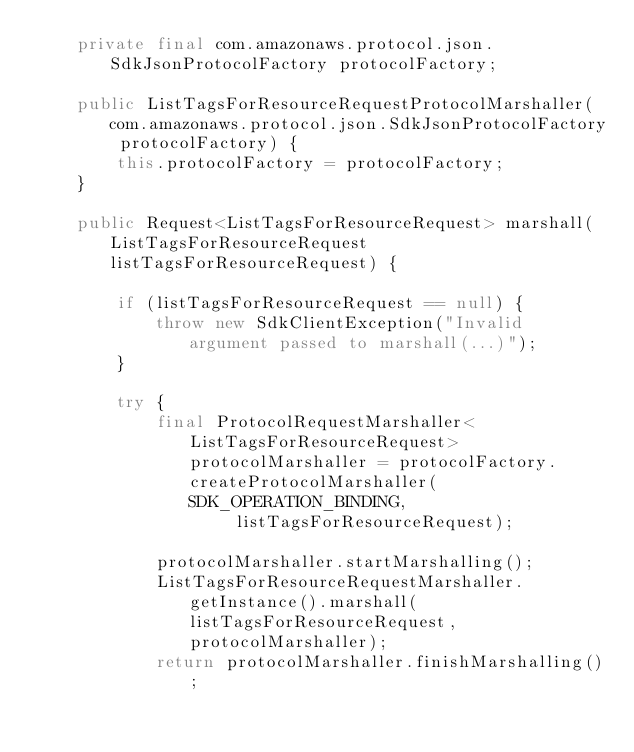<code> <loc_0><loc_0><loc_500><loc_500><_Java_>    private final com.amazonaws.protocol.json.SdkJsonProtocolFactory protocolFactory;

    public ListTagsForResourceRequestProtocolMarshaller(com.amazonaws.protocol.json.SdkJsonProtocolFactory protocolFactory) {
        this.protocolFactory = protocolFactory;
    }

    public Request<ListTagsForResourceRequest> marshall(ListTagsForResourceRequest listTagsForResourceRequest) {

        if (listTagsForResourceRequest == null) {
            throw new SdkClientException("Invalid argument passed to marshall(...)");
        }

        try {
            final ProtocolRequestMarshaller<ListTagsForResourceRequest> protocolMarshaller = protocolFactory.createProtocolMarshaller(SDK_OPERATION_BINDING,
                    listTagsForResourceRequest);

            protocolMarshaller.startMarshalling();
            ListTagsForResourceRequestMarshaller.getInstance().marshall(listTagsForResourceRequest, protocolMarshaller);
            return protocolMarshaller.finishMarshalling();</code> 